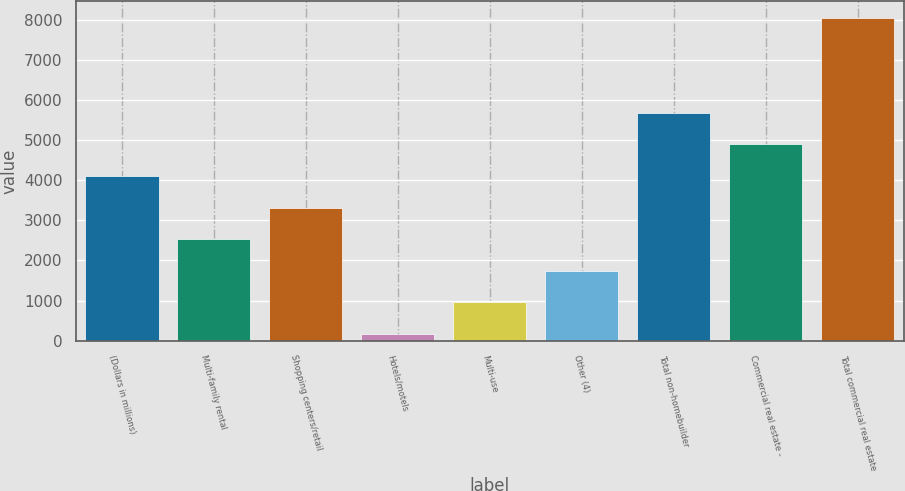Convert chart to OTSL. <chart><loc_0><loc_0><loc_500><loc_500><bar_chart><fcel>(Dollars in millions)<fcel>Multi-family rental<fcel>Shopping centers/retail<fcel>Hotels/motels<fcel>Multi-use<fcel>Other (4)<fcel>Total non-homebuilder<fcel>Commercial real estate -<fcel>Total commercial real estate<nl><fcel>4111.5<fcel>2530.9<fcel>3321.2<fcel>160<fcel>950.3<fcel>1740.6<fcel>5692.1<fcel>4901.8<fcel>8063<nl></chart> 